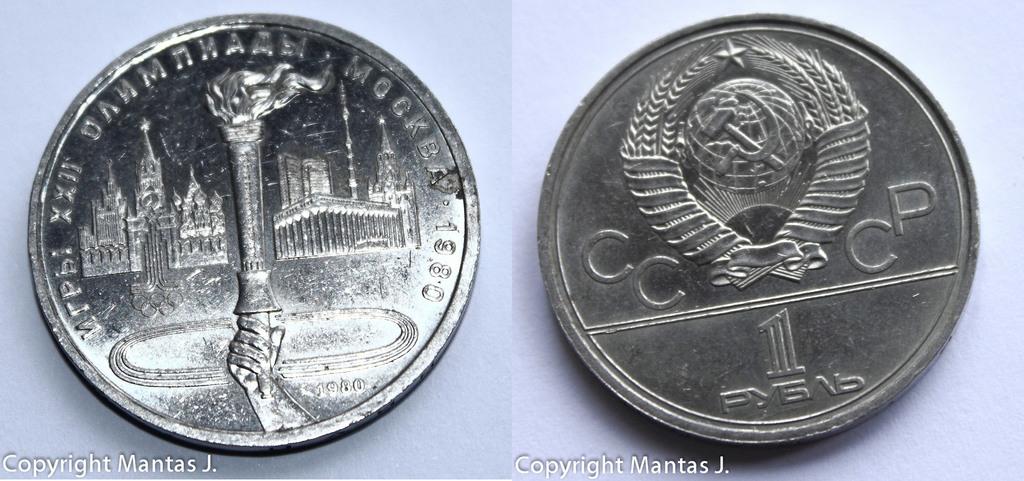How much is this coin worth?
Make the answer very short. 1. What are the four letters on the right coin?
Keep it short and to the point. Cccp. 